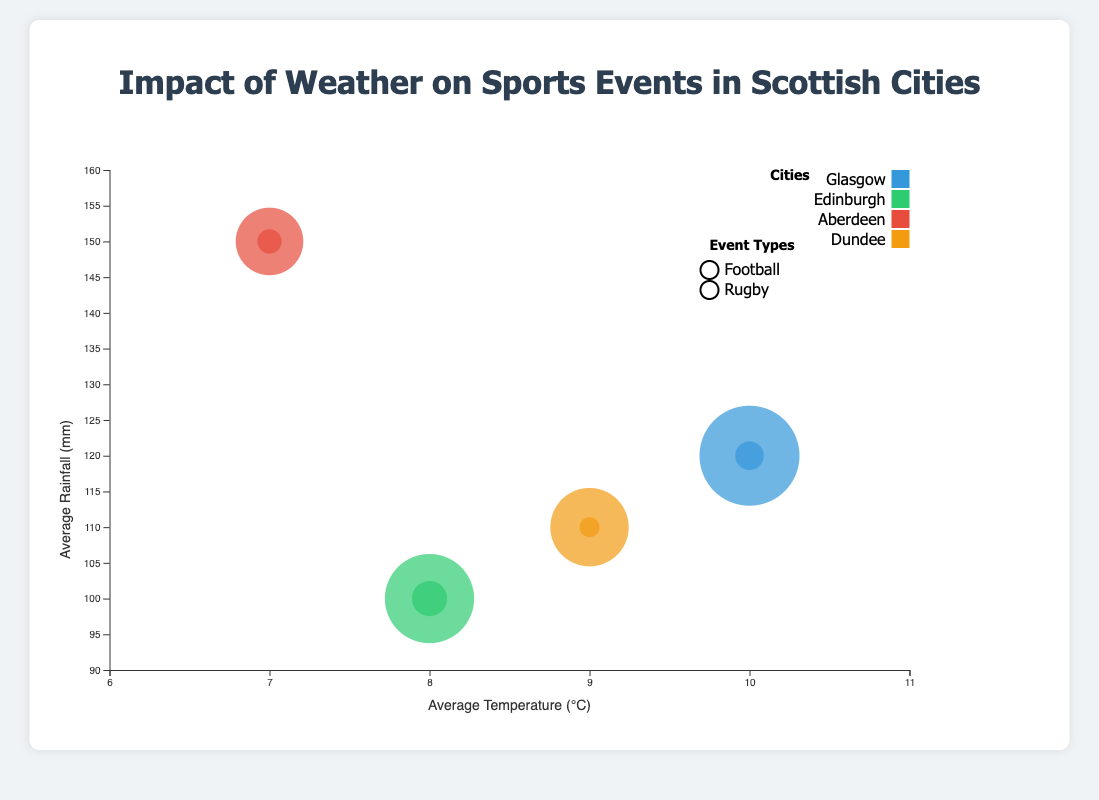What does the x-axis represent? The x-axis represents the average temperature in Celsius for the cities and event types shown in the bubble chart.
Answer: Average temperature in Celsius What city's rugby events have the highest frequency per year? By observing the size of the bubbles and identifying the one labeled "Rugby" with the largest size, it is Glasgow that has the rugby events with the highest frequency at 12 events per year.
Answer: Glasgow Between Glasgow and Aberdeen, which city has football events in higher rainfall conditions? Comparing the y-axis values for bubbles representing football events in each city, Aberdeen’s bubble is higher on the y-axis, indicating a higher average rainfall of 150 mm compared to Glasgow's 120 mm.
Answer: Aberdeen What are the ranges of the x-axis and y-axis in the bubble chart? The x-axis ranges from 6°C to 11°C, and the y-axis ranges from 90 mm to 160 mm.
Answer: 6°C to 11°C and 90 mm to 160 mm How does event frequency per year correlate with temperature and rainfall across the different cities? By analyzing the bubble sizes and their positions on the x and y axes, we see that events do not have a straightforward correlation with temperature and rainfall. For instance, Glasgow has the highest football event frequency yet a moderate temperature and rainfall, while Aberdeen has fewer events in more extreme rainfall conditions.
Answer: No straightforward correlation Which city has the least frequency of football events, and what might the reasons be based on the chart? By observing the bubble sizes, Aberdeen has the smallest bubble for football events with only 30 events per year, possibly due to its higher average rainfall of 150mm and lower average temperature of 7°C.
Answer: Aberdeen Comparing Edinburgh and Dundee, which city has more balanced event frequencies for both football and rugby? Comparing the sizes of both pairs of bubbles for each city, Edinburgh shows closer values with 40 football and 15 rugby events, while Dundee has 35 football and only 8 rugby events.
Answer: Edinburgh What visual clue helps to differentiate between the event types in the chart? The legend and the different colored outlines for the event types—such as circles for football and squares for rugby—serve as visual clues to differentiate between them.
Answer: Types of outlines What is the average temperature for all cities represented combined? Adding all average temperatures from Glasgow, Edinburgh, Aberdeen, and Dundee (10+10+8+8+7+7+9+9) and dividing by the number of data points (8), the average temperature comes out to be (68/8) = 8.5°C.
Answer: 8.5°C 